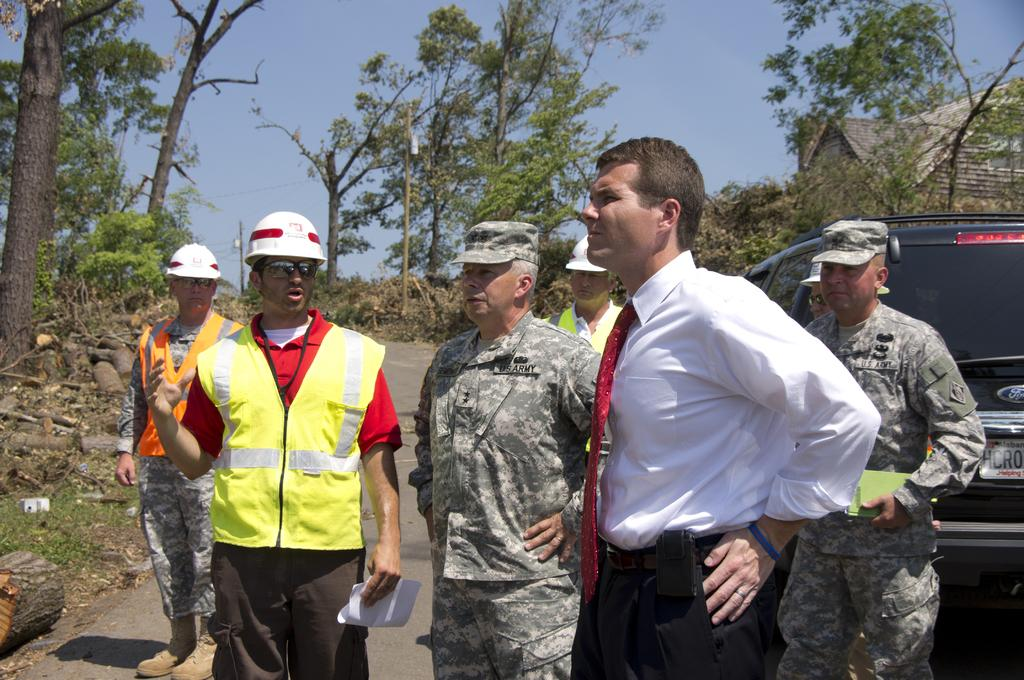What are the people in the image doing? The people in the image are standing on the road. What type of vehicle can be seen in the image? There is a motor vehicle in the image. What structures are visible in the image? There are buildings in the image. What type of vegetation is present in the image? Trees are present in the image. What man-made structures are visible in the image? Electric poles are visible in the image. What else is connected to the electric poles? Electric cables are present in the image. What other objects can be seen on the ground in the image? Logs are visible in the image. What part of the natural environment is visible in the image? The sky is visible in the image. Can you see a kitty playing on the dock in the image? There is no dock or kitty present in the image. What type of vacation are the people in the image enjoying? The image does not provide any information about a vacation or the people's activities. 